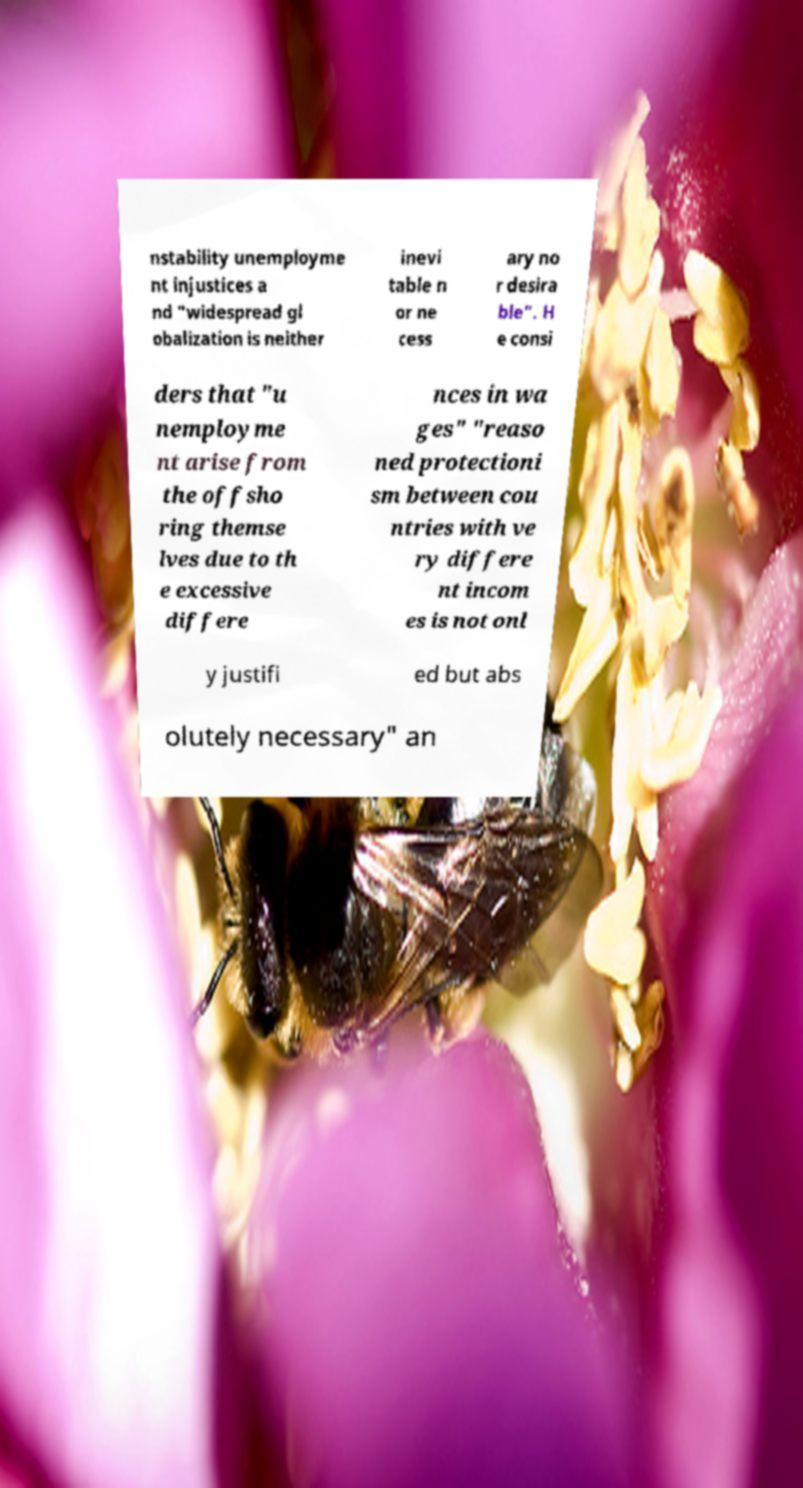Could you extract and type out the text from this image? nstability unemployme nt injustices a nd "widespread gl obalization is neither inevi table n or ne cess ary no r desira ble". H e consi ders that "u nemployme nt arise from the offsho ring themse lves due to th e excessive differe nces in wa ges" "reaso ned protectioni sm between cou ntries with ve ry differe nt incom es is not onl y justifi ed but abs olutely necessary" an 